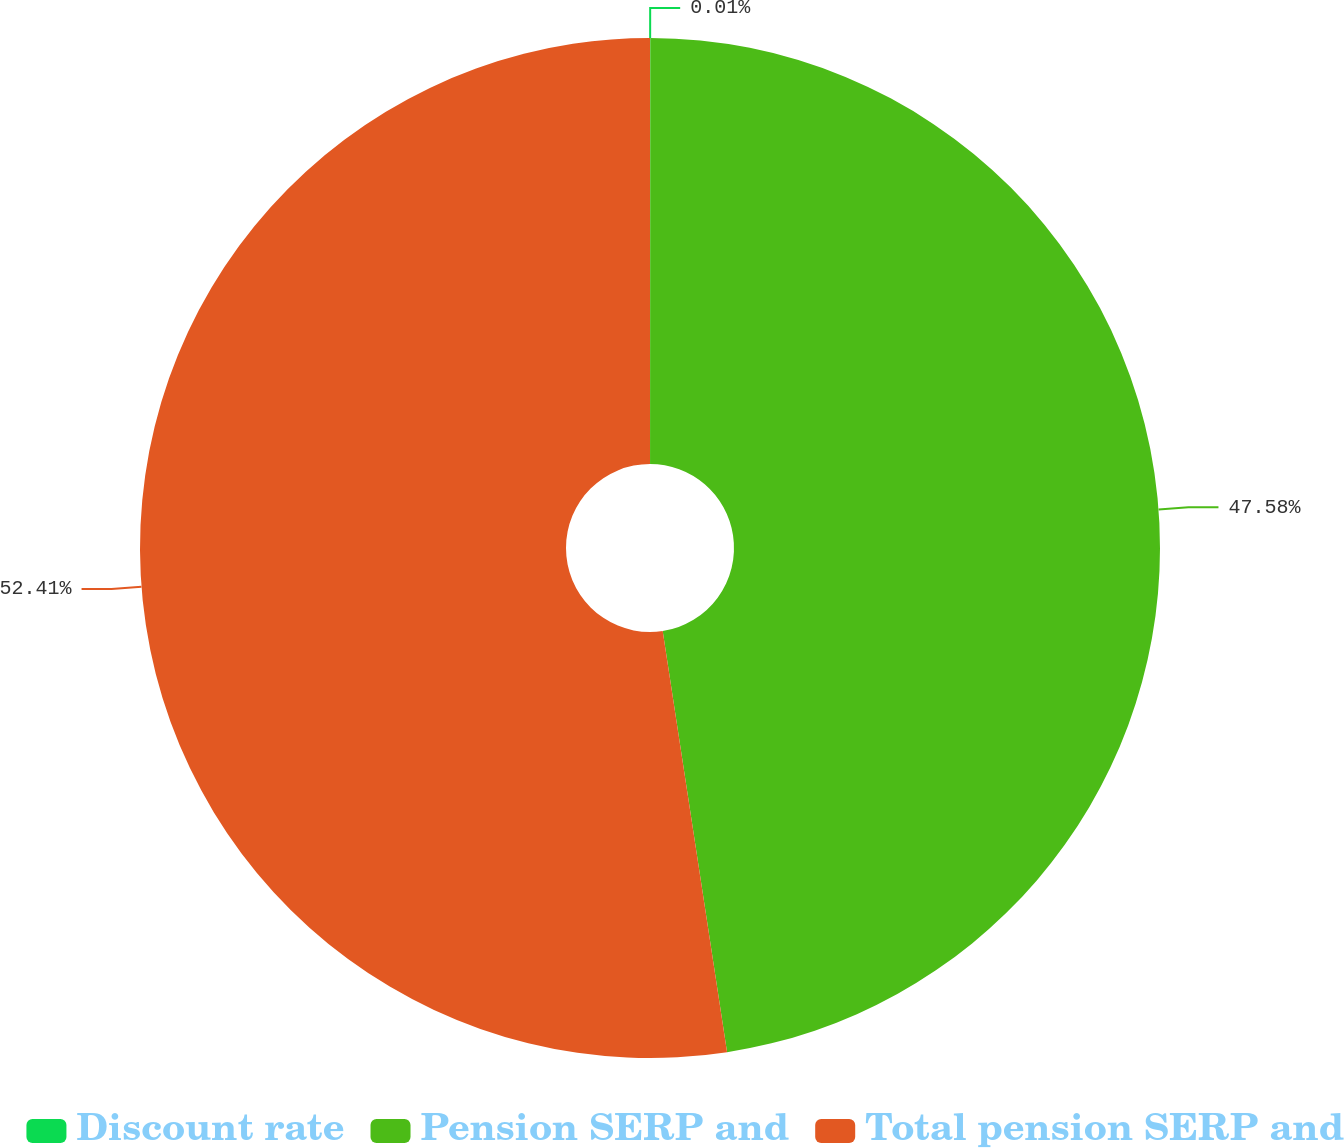Convert chart. <chart><loc_0><loc_0><loc_500><loc_500><pie_chart><fcel>Discount rate<fcel>Pension SERP and<fcel>Total pension SERP and<nl><fcel>0.01%<fcel>47.58%<fcel>52.42%<nl></chart> 